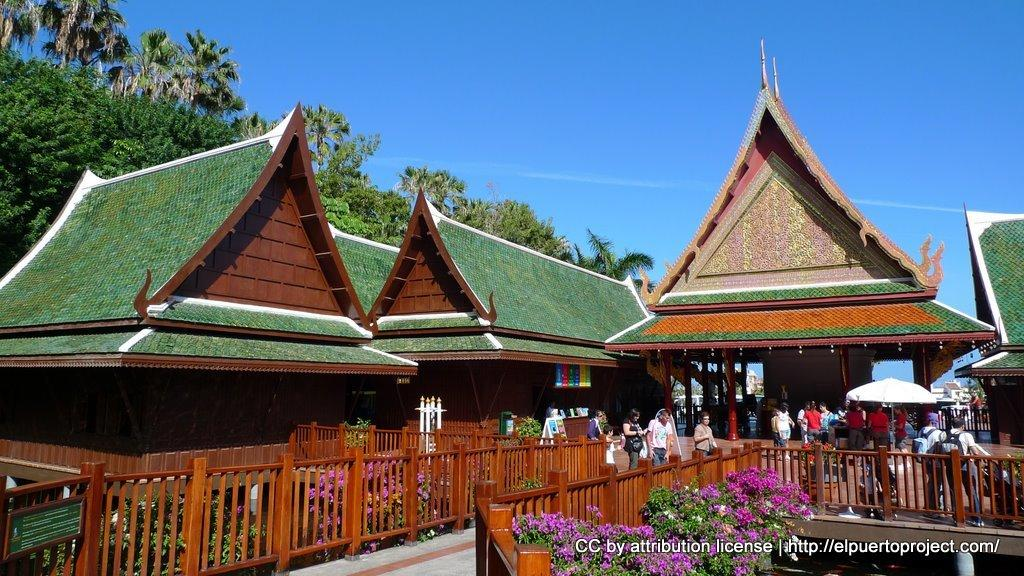What can be seen in the front of the image? There are flowers and railings in the front of the image. What is visible in the background of the image? There are houses, persons, and trees in the background of the image. What time is shown on the clock in the image? There is no clock present in the image. What type of lunch is being served to the persons in the image? There is no lunch or indication of food in the image. 